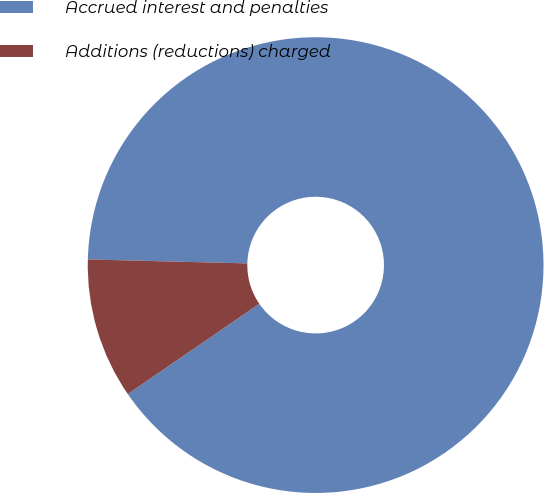Convert chart to OTSL. <chart><loc_0><loc_0><loc_500><loc_500><pie_chart><fcel>Accrued interest and penalties<fcel>Additions (reductions) charged<nl><fcel>90.03%<fcel>9.97%<nl></chart> 